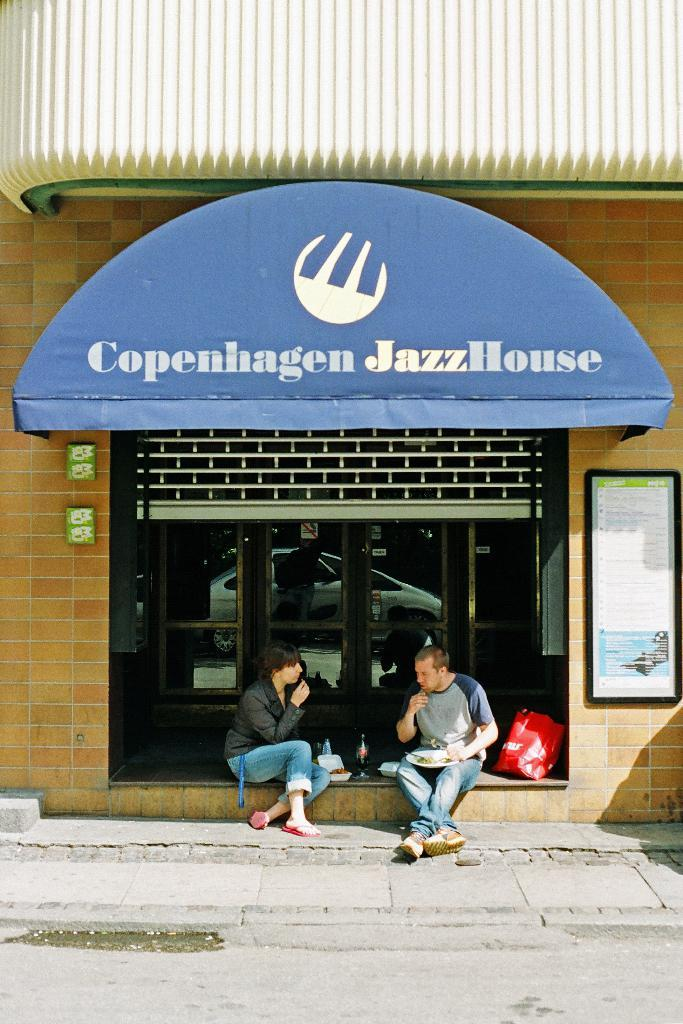How many people are in the image? There are two persons in the image. What are the two persons doing in the image? The two persons are sitting. Where are the two persons located in the image? The two persons are in front of a store. What is placed in front of the two persons? There are eatables in front of the two persons. What type of dog is guiding the committee in the image? There is no dog or committee present in the image. 